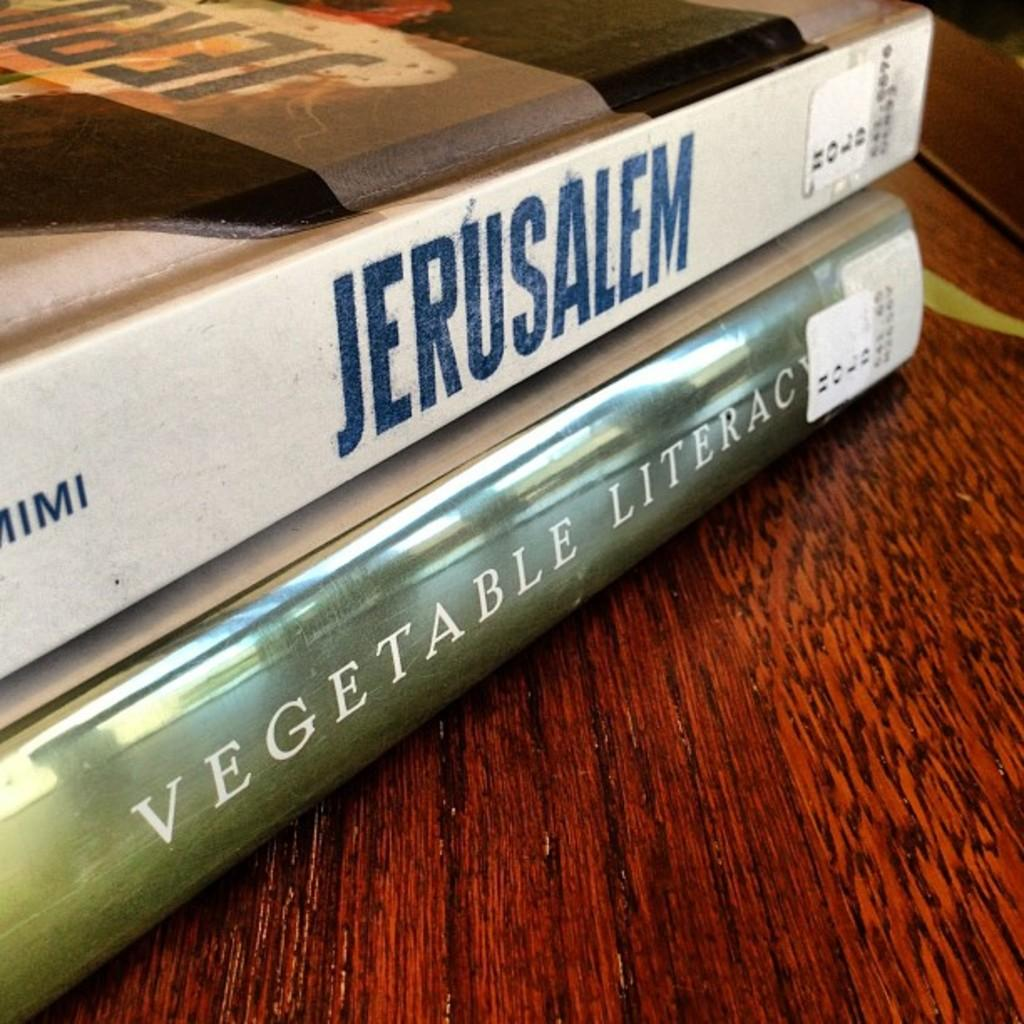Provide a one-sentence caption for the provided image. The city mentioned on the top book is Jerusalem. 